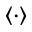Convert formula to latex. <formula><loc_0><loc_0><loc_500><loc_500>\langle \cdot \rangle</formula> 